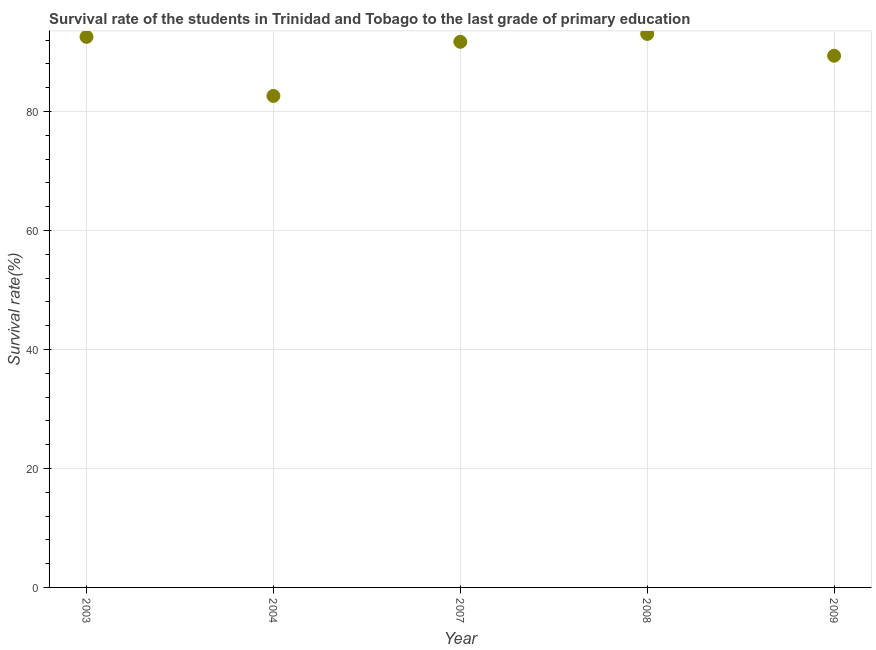What is the survival rate in primary education in 2004?
Make the answer very short. 82.63. Across all years, what is the maximum survival rate in primary education?
Offer a very short reply. 93.05. Across all years, what is the minimum survival rate in primary education?
Give a very brief answer. 82.63. In which year was the survival rate in primary education maximum?
Make the answer very short. 2008. In which year was the survival rate in primary education minimum?
Provide a succinct answer. 2004. What is the sum of the survival rate in primary education?
Your answer should be compact. 449.36. What is the difference between the survival rate in primary education in 2004 and 2009?
Make the answer very short. -6.75. What is the average survival rate in primary education per year?
Offer a terse response. 89.87. What is the median survival rate in primary education?
Your response must be concise. 91.73. Do a majority of the years between 2003 and 2008 (inclusive) have survival rate in primary education greater than 44 %?
Your answer should be compact. Yes. What is the ratio of the survival rate in primary education in 2003 to that in 2009?
Keep it short and to the point. 1.04. Is the survival rate in primary education in 2004 less than that in 2008?
Provide a succinct answer. Yes. What is the difference between the highest and the second highest survival rate in primary education?
Ensure brevity in your answer.  0.5. Is the sum of the survival rate in primary education in 2003 and 2008 greater than the maximum survival rate in primary education across all years?
Offer a terse response. Yes. What is the difference between the highest and the lowest survival rate in primary education?
Your answer should be compact. 10.42. In how many years, is the survival rate in primary education greater than the average survival rate in primary education taken over all years?
Offer a terse response. 3. Does the survival rate in primary education monotonically increase over the years?
Keep it short and to the point. No. Are the values on the major ticks of Y-axis written in scientific E-notation?
Make the answer very short. No. Does the graph contain any zero values?
Provide a short and direct response. No. What is the title of the graph?
Keep it short and to the point. Survival rate of the students in Trinidad and Tobago to the last grade of primary education. What is the label or title of the Y-axis?
Provide a succinct answer. Survival rate(%). What is the Survival rate(%) in 2003?
Keep it short and to the point. 92.56. What is the Survival rate(%) in 2004?
Ensure brevity in your answer.  82.63. What is the Survival rate(%) in 2007?
Make the answer very short. 91.73. What is the Survival rate(%) in 2008?
Your answer should be compact. 93.05. What is the Survival rate(%) in 2009?
Give a very brief answer. 89.39. What is the difference between the Survival rate(%) in 2003 and 2004?
Your answer should be very brief. 9.92. What is the difference between the Survival rate(%) in 2003 and 2007?
Ensure brevity in your answer.  0.83. What is the difference between the Survival rate(%) in 2003 and 2008?
Ensure brevity in your answer.  -0.5. What is the difference between the Survival rate(%) in 2003 and 2009?
Make the answer very short. 3.17. What is the difference between the Survival rate(%) in 2004 and 2007?
Make the answer very short. -9.1. What is the difference between the Survival rate(%) in 2004 and 2008?
Give a very brief answer. -10.42. What is the difference between the Survival rate(%) in 2004 and 2009?
Ensure brevity in your answer.  -6.75. What is the difference between the Survival rate(%) in 2007 and 2008?
Your answer should be compact. -1.33. What is the difference between the Survival rate(%) in 2007 and 2009?
Ensure brevity in your answer.  2.34. What is the difference between the Survival rate(%) in 2008 and 2009?
Provide a succinct answer. 3.67. What is the ratio of the Survival rate(%) in 2003 to that in 2004?
Your answer should be very brief. 1.12. What is the ratio of the Survival rate(%) in 2003 to that in 2009?
Give a very brief answer. 1.03. What is the ratio of the Survival rate(%) in 2004 to that in 2007?
Provide a short and direct response. 0.9. What is the ratio of the Survival rate(%) in 2004 to that in 2008?
Offer a terse response. 0.89. What is the ratio of the Survival rate(%) in 2004 to that in 2009?
Your answer should be compact. 0.92. What is the ratio of the Survival rate(%) in 2007 to that in 2008?
Keep it short and to the point. 0.99. What is the ratio of the Survival rate(%) in 2007 to that in 2009?
Offer a terse response. 1.03. What is the ratio of the Survival rate(%) in 2008 to that in 2009?
Make the answer very short. 1.04. 